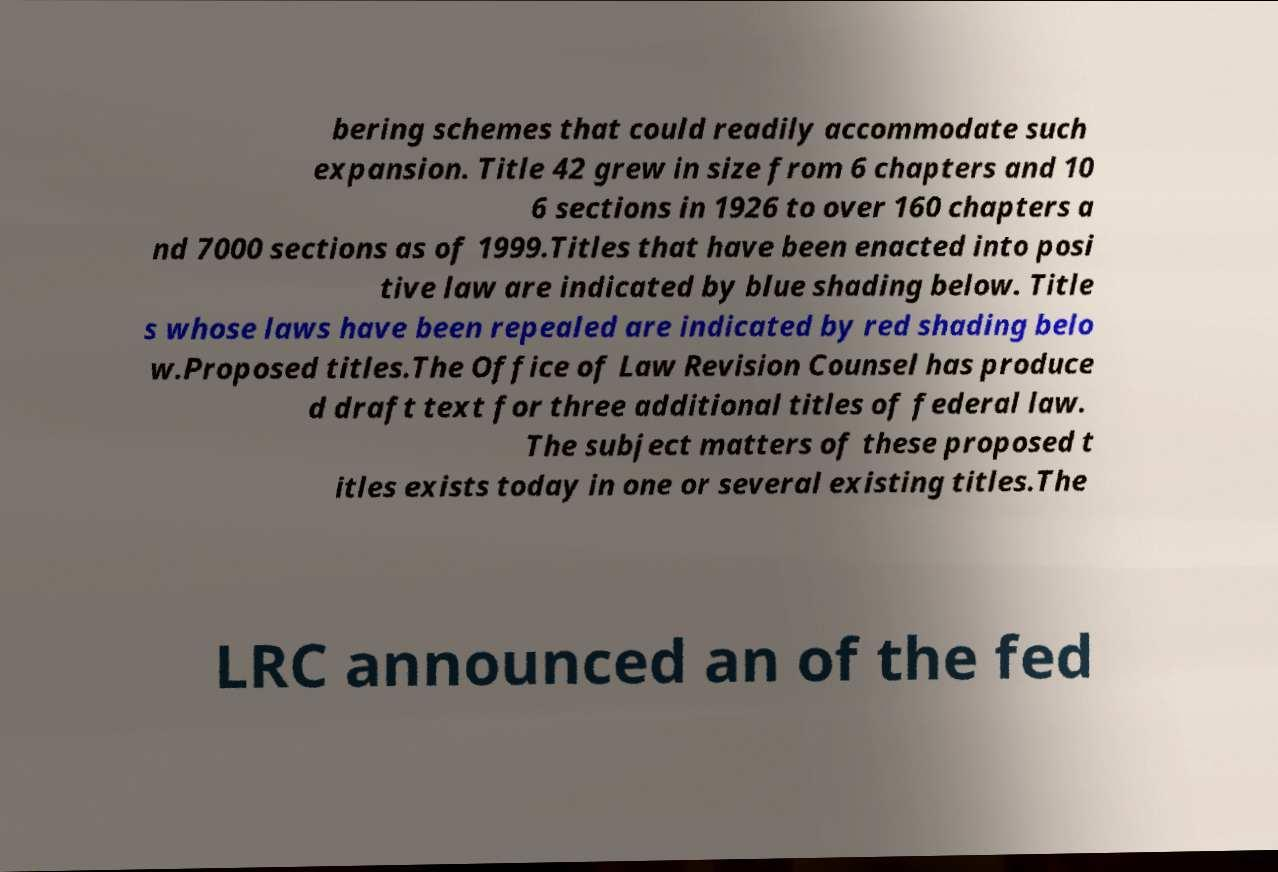Could you assist in decoding the text presented in this image and type it out clearly? bering schemes that could readily accommodate such expansion. Title 42 grew in size from 6 chapters and 10 6 sections in 1926 to over 160 chapters a nd 7000 sections as of 1999.Titles that have been enacted into posi tive law are indicated by blue shading below. Title s whose laws have been repealed are indicated by red shading belo w.Proposed titles.The Office of Law Revision Counsel has produce d draft text for three additional titles of federal law. The subject matters of these proposed t itles exists today in one or several existing titles.The LRC announced an of the fed 